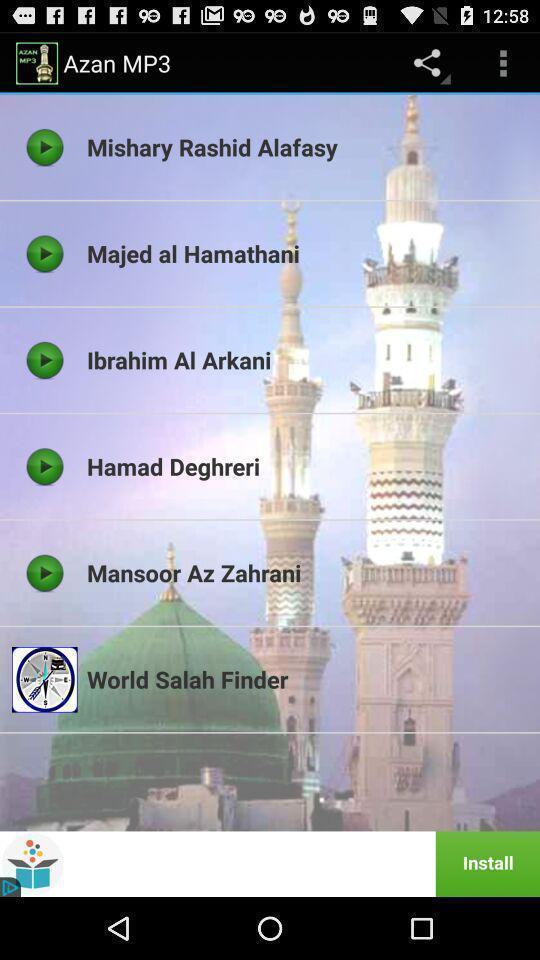Tell me what you see in this picture. Screen shows list of songs in a music app. 